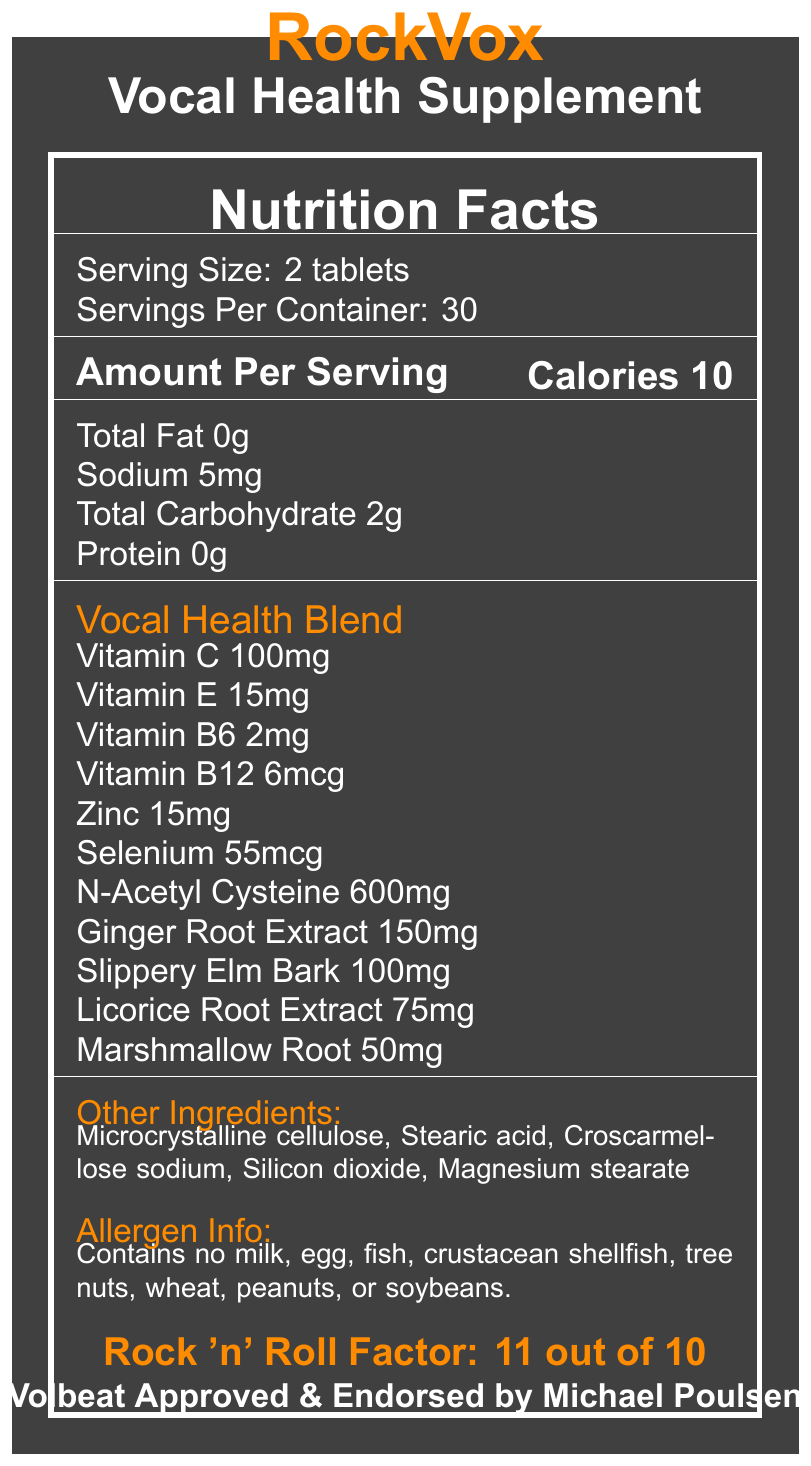What is the serving size for RockVox? The document states the serving size is "2 tablets".
Answer: 2 tablets How many servings are in one container? The document mentions "Servings Per Container: 30".
Answer: 30 What is the amount of Vitamin C per serving? Under "Vocal Health Blend", the amount of Vitamin C is listed as "100mg".
Answer: 100mg How many calories are there per serving? Under the "Amount Per Serving" section, it states "Calories 10".
Answer: 10 Which ingredient has the highest concentration in the Vocal Health Blend? In the "Vocal Health Blend", N-Acetyl Cysteine has the highest concentration at "600mg".
Answer: N-Acetyl Cysteine How much sodium is in each serving? The document lists sodium content as "5mg".
Answer: 5mg Does the supplement contain any allergens like milk or peanuts? The allergen info states it contains no milk, egg, fish, crustacean shellfish, tree nuts, wheat, peanuts, or soybeans.
Answer: No Who endorses the RockVox supplement? The document states that it is "endorsed by Michael Poulsen, lead vocalist of Volbeat".
Answer: Michael Poulsen, lead vocalist of Volbeat What is the primary function of the RockVox supplement mentioned? Under the "Product Benefits", it lists "Supports vocal cord health" as one of the main benefits.
Answer: Supports vocal cord health How should the RockVox supplement be stored? A. In a refrigerator B. In a cool, dry place away from direct sunlight C. At room temperature The document states, "Store in a cool, dry place away from direct sunlight".
Answer: B Which of these ingredients are not in RockVox? A. Ginger Root Extract B. Silicon Dioxide C. Sugar The listed ingredients do not include sugar.
Answer: C Is RockVox approved by Volbeat? The document explicitly states "Volbeat Approved".
Answer: Yes Summarize the main details provided in the document. The summary includes the product's purpose, key ingredients, endorsement, allergen information, and storage instructions.
Answer: RockVox Vocal Health Supplement is designed to support vocal health, containing various beneficial vitamins, minerals, and herbs. It is endorsed by Michael Poulsen of Volbeat. The supplement has no common allergens and is recommended to be stored in a cool, dry place. What precaution is advised for people who are pregnant, nursing, or taking medications? The warning section advises those groups of people to consult their healthcare provider.
Answer: Consult your healthcare provider before use Can this supplement be taken on an empty stomach? The document suggests taking it "preferably with meals or as directed by a healthcare professional", but does not specify if it can be taken on an empty stomach explicitly.
Answer: Not enough information What are the key vitamins included in the supplement? Under "Vocal Health Blend", these vitamins are listed with their respective amounts.
Answer: Vitamin C, Vitamin E, Vitamin B6, Vitamin B12 What additional ingredients are present in the supplement besides the Vocal Health Blend? A. Microcrystalline cellulose, Stearic acid B. Croscarmellose sodium, Silicon dioxide C. Magnesium stearate D. All of the above The document lists all of these under "Other ingredients".
Answer: D 